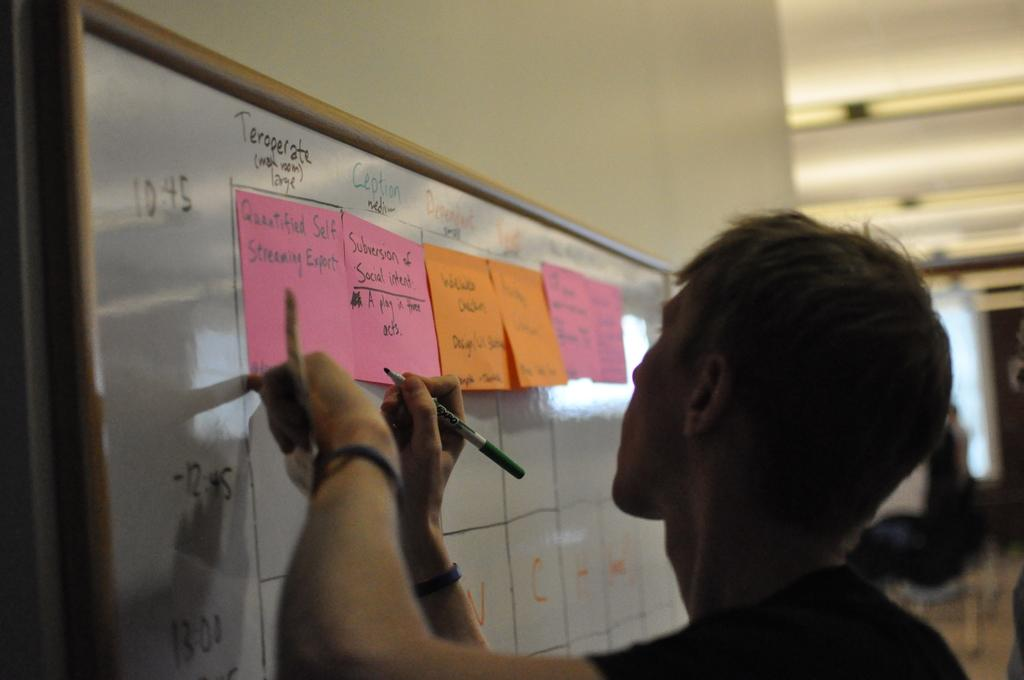<image>
Offer a succinct explanation of the picture presented. A man is writing 'Subversion of Social intent' on post it notes on a whiteboard. 